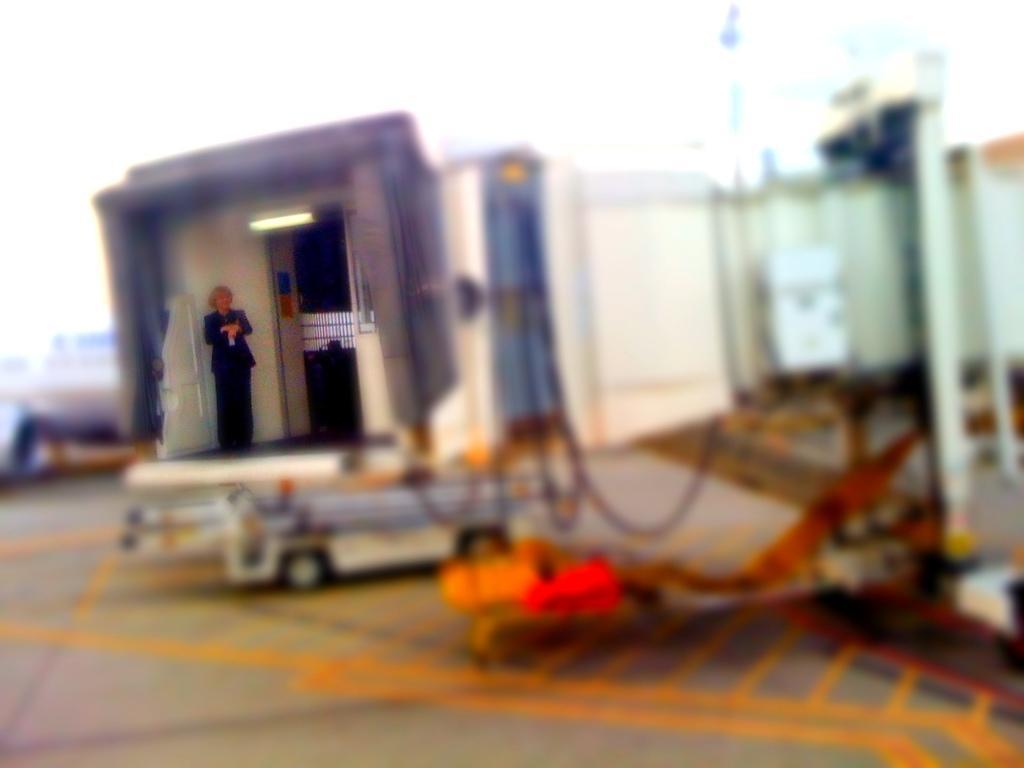How would you summarize this image in a sentence or two? This is a blur image. In the middle of this image I can see a vehicle on the road. On the vehicle a person is wearing a black color dress and standing. 